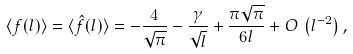Convert formula to latex. <formula><loc_0><loc_0><loc_500><loc_500>\langle f ( l ) \rangle = \langle \hat { f } ( l ) \rangle = - \frac { 4 } { \sqrt { \pi } } - \frac { \gamma } { \sqrt { l } } + \frac { \pi \sqrt { \pi } } { 6 l } + O \, \left ( l ^ { - 2 } \right ) ,</formula> 